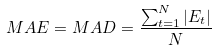<formula> <loc_0><loc_0><loc_500><loc_500>\ M A E = M A D = { \frac { \sum _ { t = 1 } ^ { N } | E _ { t } | } { N } }</formula> 